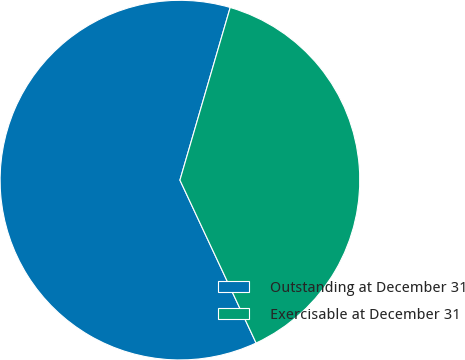Convert chart to OTSL. <chart><loc_0><loc_0><loc_500><loc_500><pie_chart><fcel>Outstanding at December 31<fcel>Exercisable at December 31<nl><fcel>61.47%<fcel>38.53%<nl></chart> 